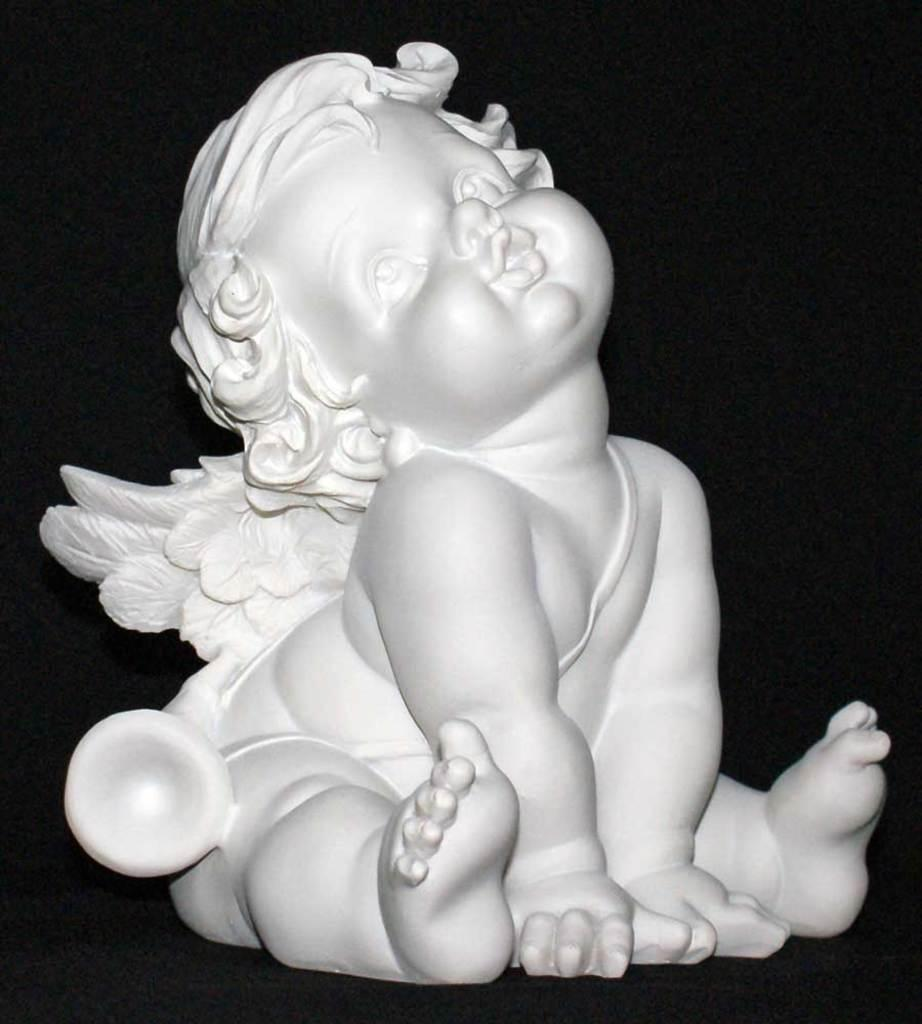What is the main subject of the image? There is a statue of a baby in the image. What color is the statue? The statue is white in color. What can be seen in the background of the image? The background of the image is black. What type of nerve can be seen in the image? There is no nerve present in the image; it features a statue of a baby. How many chickens are visible in the image? There are no chickens present in the image. 